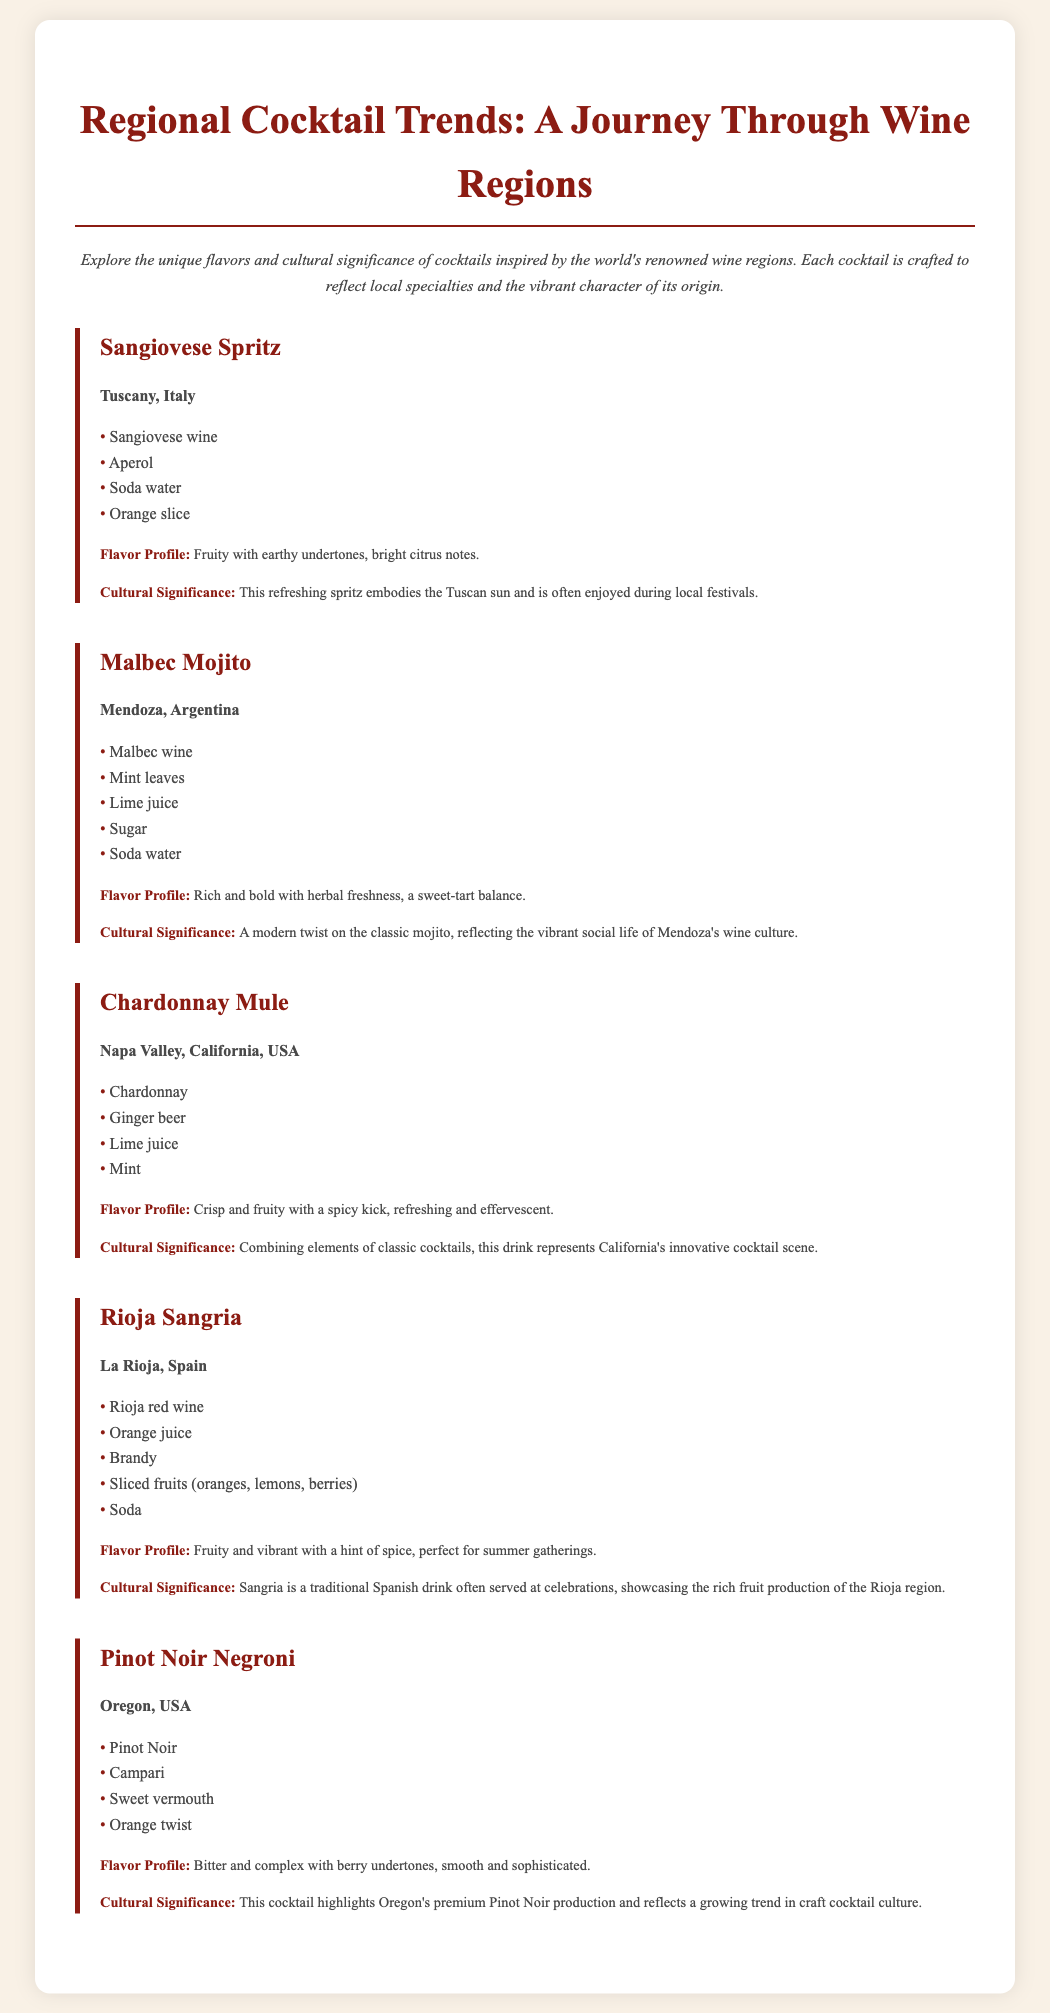What cocktail is inspired by Tuscany? The cocktail specifically mentioned as being inspired by Tuscany is the Sangiovese Spritz.
Answer: Sangiovese Spritz What is the primary wine used in the Malbec Mojito? The primary wine used in the Malbec Mojito is Malbec wine.
Answer: Malbec wine Which cocktail features ginger beer as an ingredient? The cocktail that features ginger beer is the Chardonnay Mule.
Answer: Chardonnay Mule What fruit is commonly included in Rioja Sangria? The common fruits included in Rioja Sangria are oranges, lemons, and berries.
Answer: Oranges, lemons, berries What is the cultural significance of the Pinot Noir Negroni? The cultural significance highlights Oregon's premium Pinot Noir production and craft cocktail culture.
Answer: Oregon's premium Pinot Noir production Which cocktail represents California's innovative cocktail scene? The cocktail that represents California's innovative cocktail scene is the Chardonnay Mule.
Answer: Chardonnay Mule What is the flavor profile of the Sangiovese Spritz? The flavor profile of the Sangiovese Spritz is fruity with earthy undertones, bright citrus notes.
Answer: Fruity with earthy undertones, bright citrus notes How many ingredients are in the Malbec Mojito? The Malbec Mojito contains five ingredients listed in the menu.
Answer: Five ingredients What region is the Rioja Sangria from? The Rioja Sangria is from La Rioja, Spain.
Answer: La Rioja, Spain 